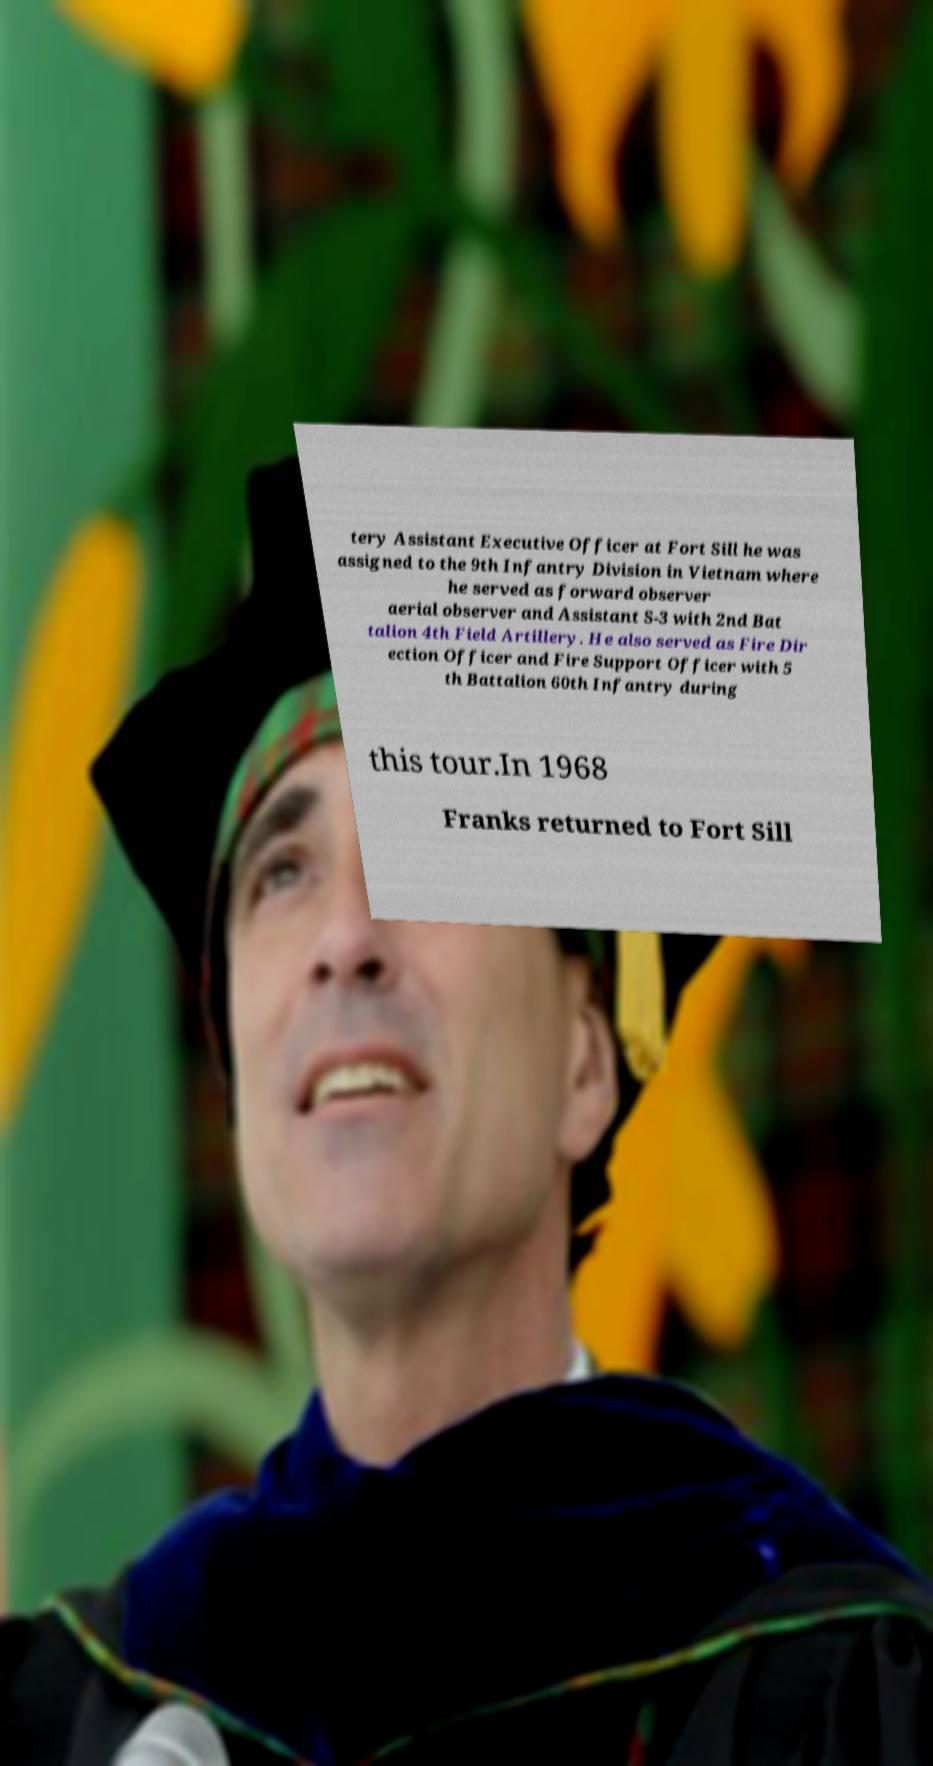Could you extract and type out the text from this image? tery Assistant Executive Officer at Fort Sill he was assigned to the 9th Infantry Division in Vietnam where he served as forward observer aerial observer and Assistant S-3 with 2nd Bat talion 4th Field Artillery. He also served as Fire Dir ection Officer and Fire Support Officer with 5 th Battalion 60th Infantry during this tour.In 1968 Franks returned to Fort Sill 